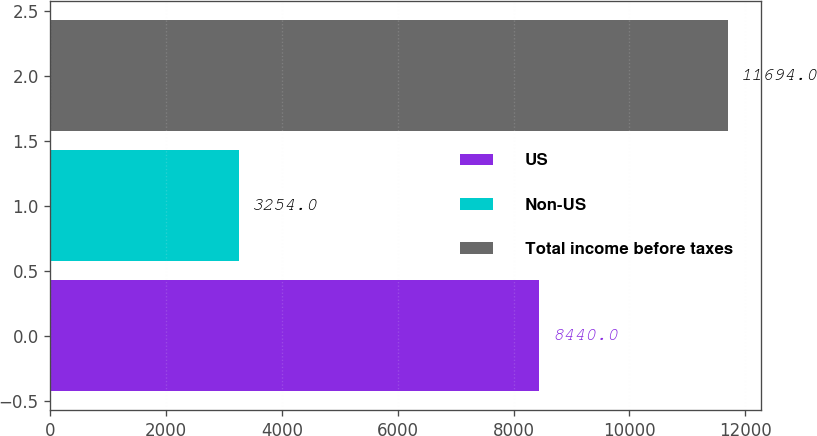Convert chart to OTSL. <chart><loc_0><loc_0><loc_500><loc_500><bar_chart><fcel>US<fcel>Non-US<fcel>Total income before taxes<nl><fcel>8440<fcel>3254<fcel>11694<nl></chart> 